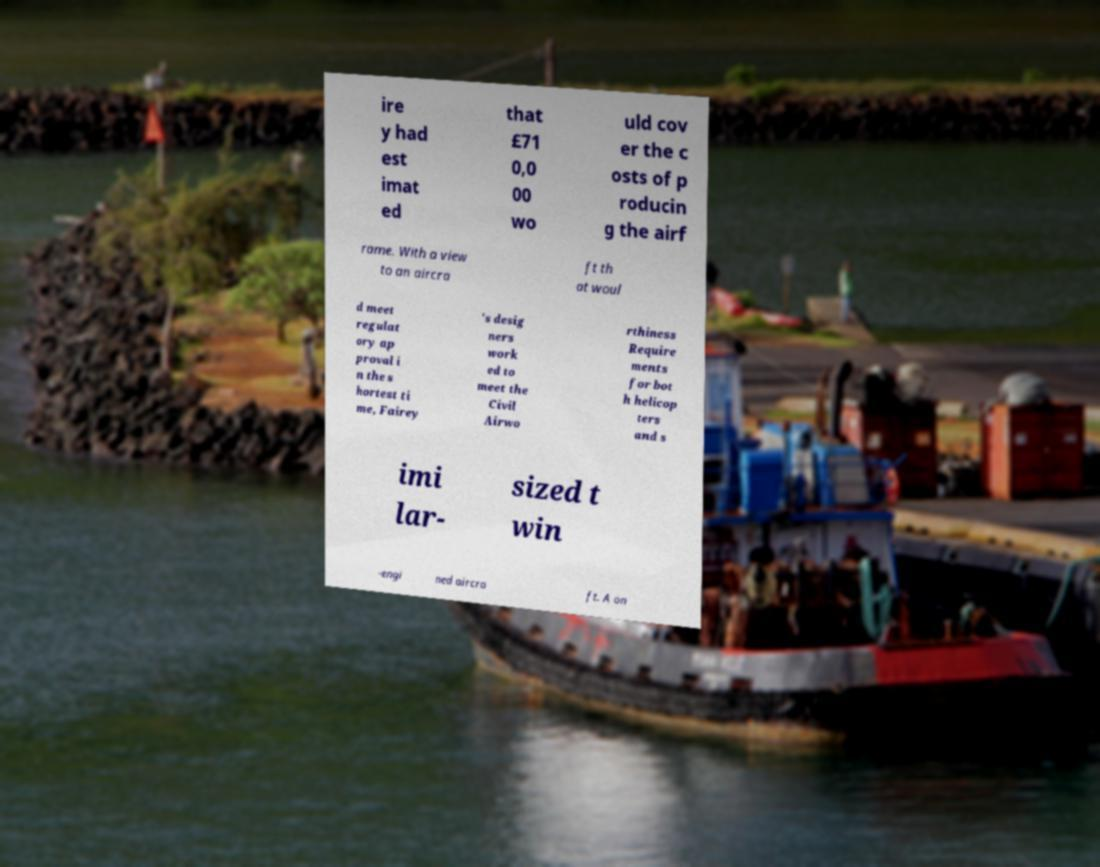Could you extract and type out the text from this image? ire y had est imat ed that £71 0,0 00 wo uld cov er the c osts of p roducin g the airf rame. With a view to an aircra ft th at woul d meet regulat ory ap proval i n the s hortest ti me, Fairey 's desig ners work ed to meet the Civil Airwo rthiness Require ments for bot h helicop ters and s imi lar- sized t win -engi ned aircra ft. A on 